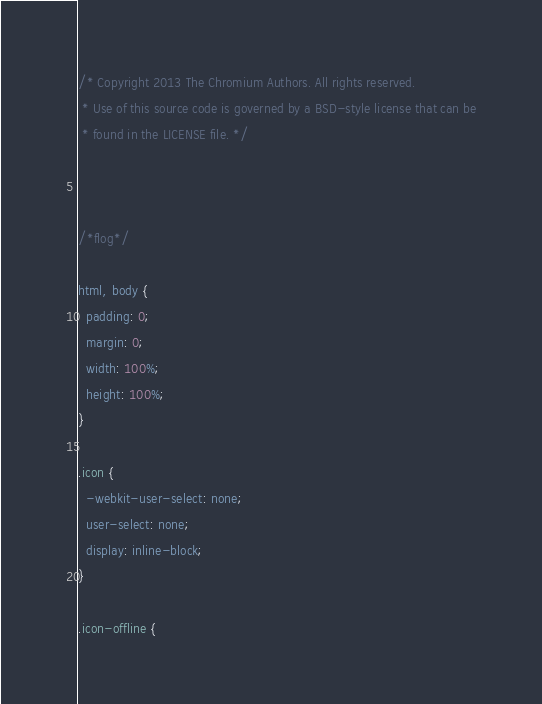<code> <loc_0><loc_0><loc_500><loc_500><_CSS_>/* Copyright 2013 The Chromium Authors. All rights reserved.
 * Use of this source code is governed by a BSD-style license that can be
 * found in the LICENSE file. */



/*flog*/

html, body {
  padding: 0;
  margin: 0;
  width: 100%;
  height: 100%;
}

.icon {
  -webkit-user-select: none;
  user-select: none;
  display: inline-block;
}

.icon-offline {</code> 